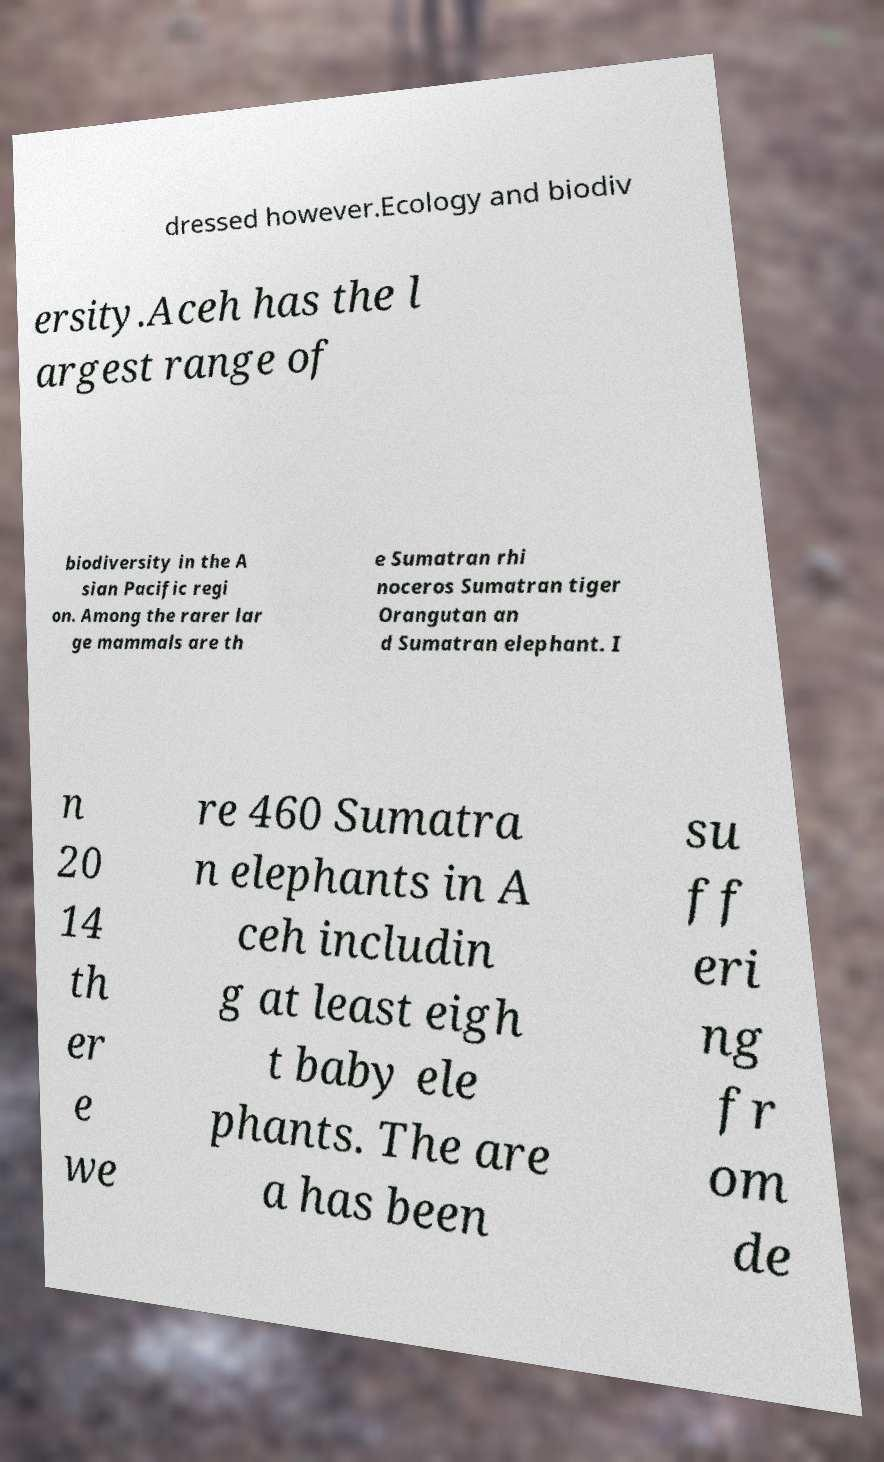Please read and relay the text visible in this image. What does it say? dressed however.Ecology and biodiv ersity.Aceh has the l argest range of biodiversity in the A sian Pacific regi on. Among the rarer lar ge mammals are th e Sumatran rhi noceros Sumatran tiger Orangutan an d Sumatran elephant. I n 20 14 th er e we re 460 Sumatra n elephants in A ceh includin g at least eigh t baby ele phants. The are a has been su ff eri ng fr om de 